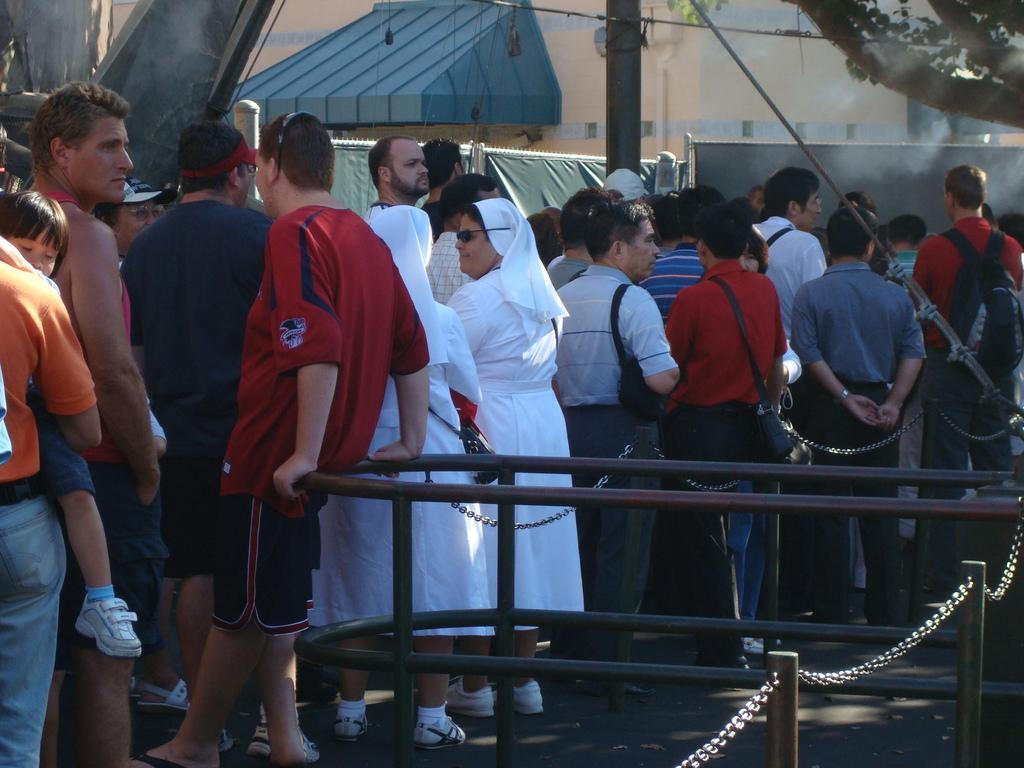How would you summarize this image in a sentence or two? In this image there are a group of people standing and some of them are holding babies, and in the foreground there are some poles and chain. And in the background there are some buildings and trees, pole and wires. At the bottom there is a walkway. 